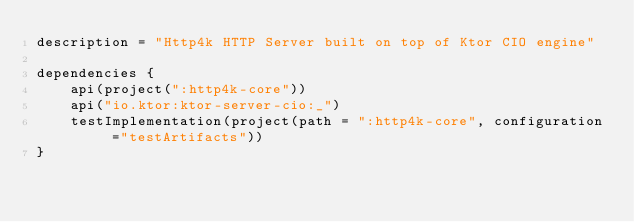<code> <loc_0><loc_0><loc_500><loc_500><_Kotlin_>description = "Http4k HTTP Server built on top of Ktor CIO engine"

dependencies {
    api(project(":http4k-core"))
    api("io.ktor:ktor-server-cio:_")
    testImplementation(project(path = ":http4k-core", configuration ="testArtifacts"))
}
</code> 